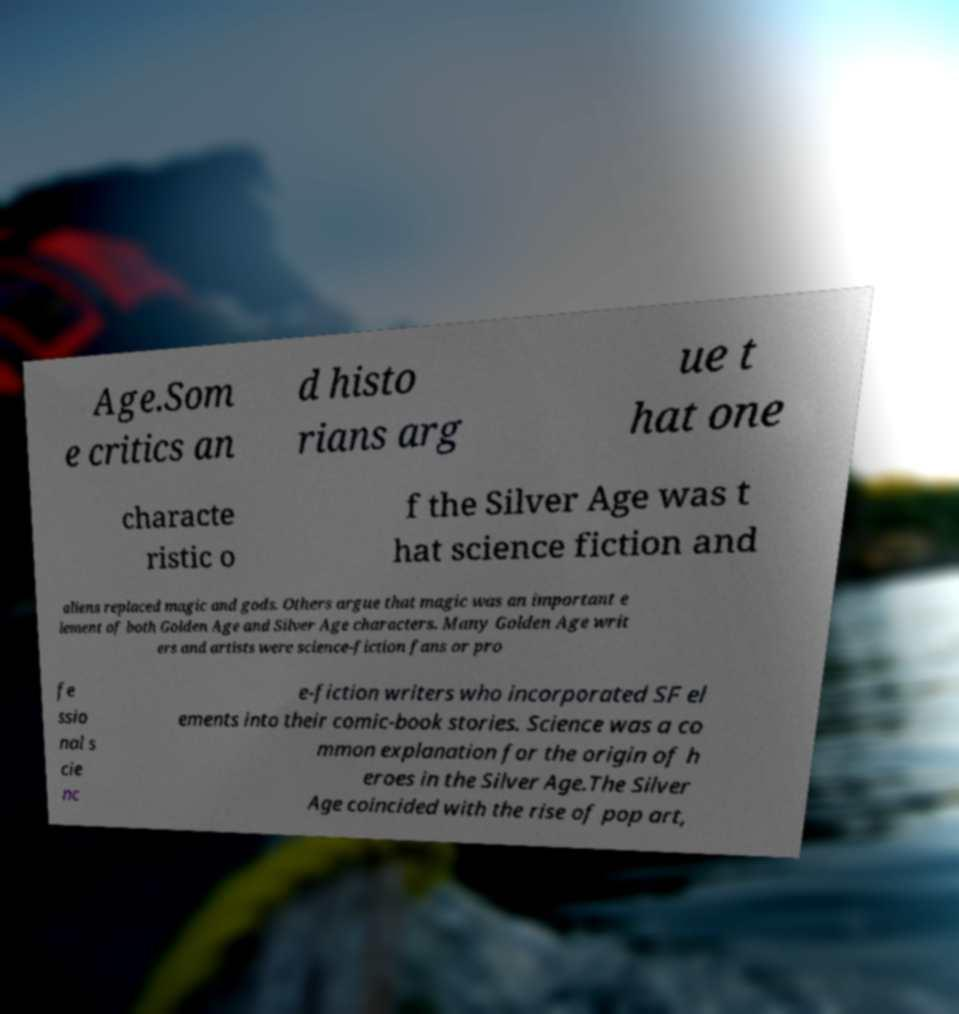I need the written content from this picture converted into text. Can you do that? Age.Som e critics an d histo rians arg ue t hat one characte ristic o f the Silver Age was t hat science fiction and aliens replaced magic and gods. Others argue that magic was an important e lement of both Golden Age and Silver Age characters. Many Golden Age writ ers and artists were science-fiction fans or pro fe ssio nal s cie nc e-fiction writers who incorporated SF el ements into their comic-book stories. Science was a co mmon explanation for the origin of h eroes in the Silver Age.The Silver Age coincided with the rise of pop art, 